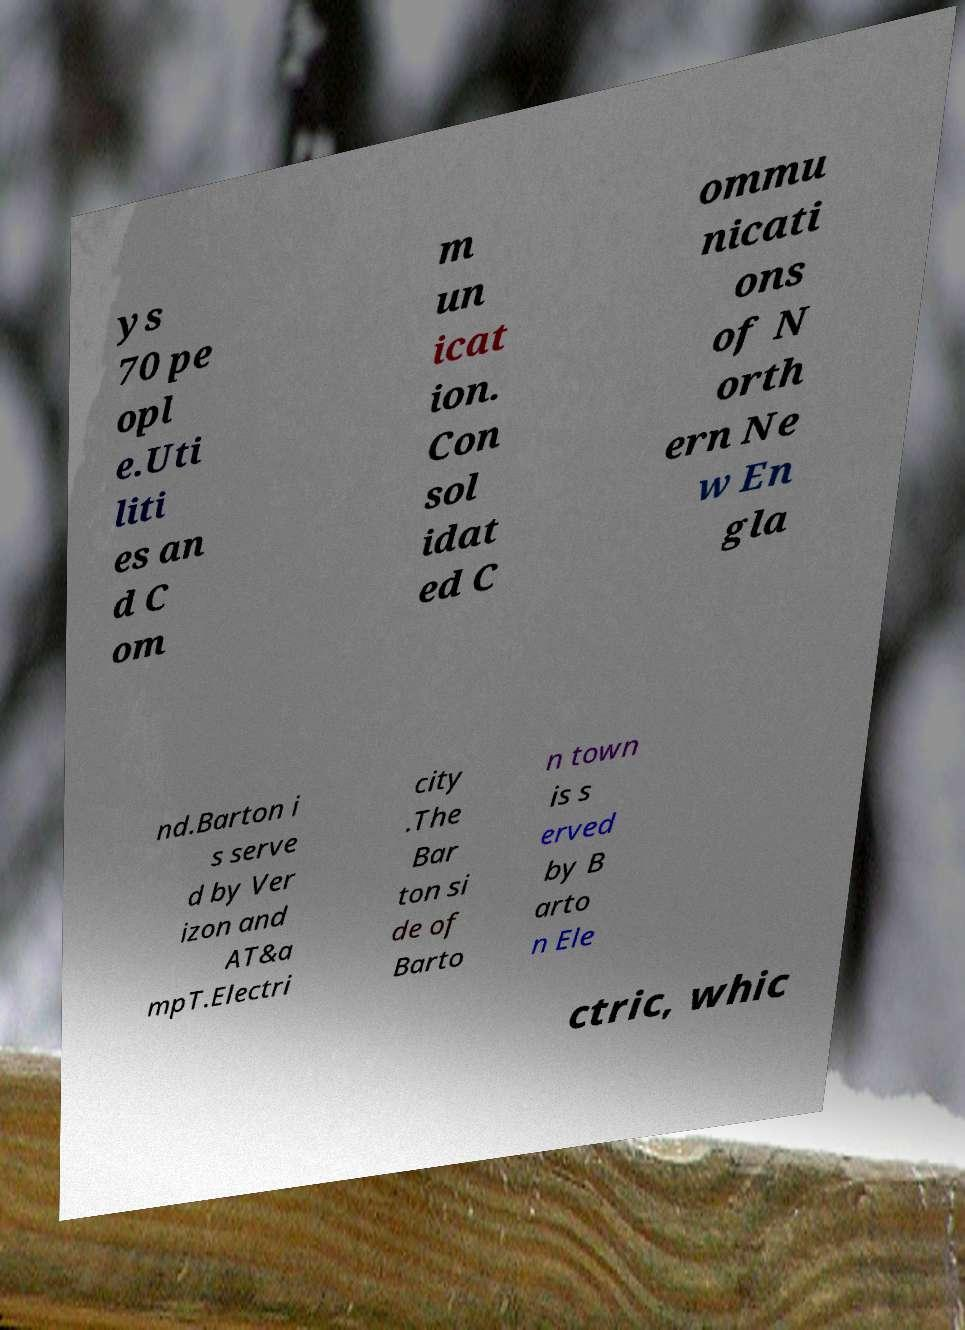Please identify and transcribe the text found in this image. ys 70 pe opl e.Uti liti es an d C om m un icat ion. Con sol idat ed C ommu nicati ons of N orth ern Ne w En gla nd.Barton i s serve d by Ver izon and AT&a mpT.Electri city .The Bar ton si de of Barto n town is s erved by B arto n Ele ctric, whic 